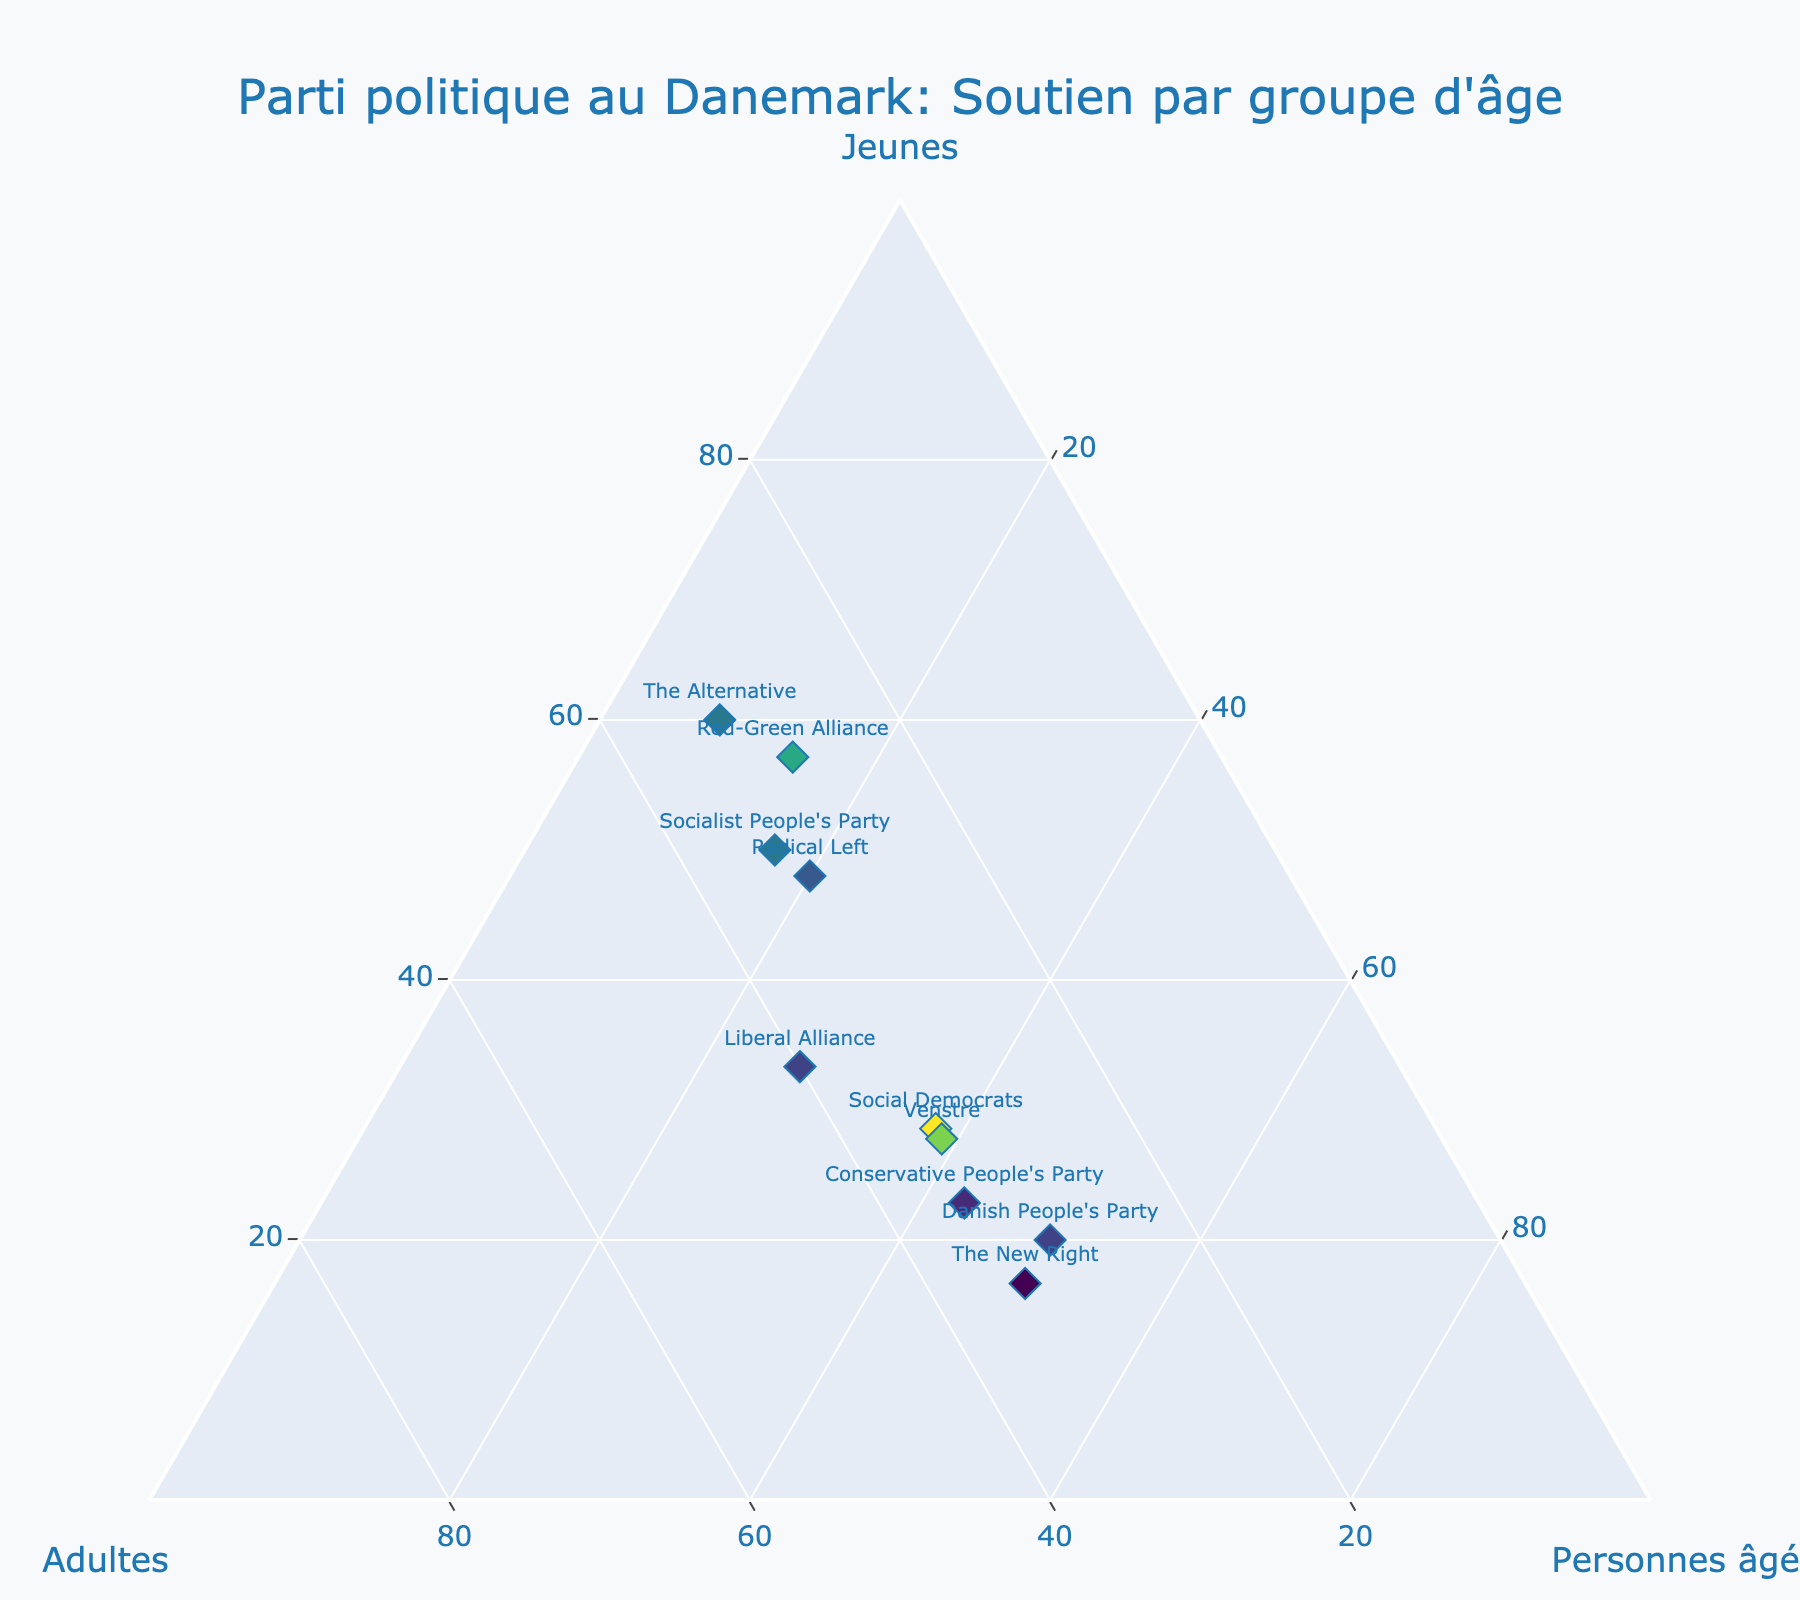What's the title of the plot? The title of the plot is located at the top center of the figure and usually presented in larger font size and distinct color to stand out.
Answer: Parti politique au Danemark: Soutien par groupe d'âge How many data points represent political parties in the plot? Each data point represents one political party, which can be identified by the text labels next to each marker. By counting these labels, you can find the number of political parties.
Answer: 10 Which political party has the highest support among the elderly? Look for the data point that is closest to the axis labeled "Personnes âgées" and observe the associated text label.
Answer: Social Democrats Which age group has the highest support for the "Red-Green Alliance"? Locate the data point labeled "Red-Green Alliance" and observe its position relative to the three axes.
Answer: Youth Is the support of "Venstre" more evenly distributed among the age groups compared to "The New Right"? Compare the positions of the data points for "Venstre" and "The New Right". "Venstre" is closer to the center of the ternary plot, indicating more even support across all age groups than "The New Right", which is closer to the elderly axis.
Answer: Yes What's the combined support in the elderly group for "Radical Left" and "The Alternative"? Identify the support values from the elderly group for both "Radical Left" (5) and "The Alternative" (2), then sum them up: 5 + 2 = 7.
Answer: 7 Which party has near equal support between adults and elderly but smallest support among the youth? Look for a data point that is positioned between the "Adultes" and "Personnes âgées" axes but closer to the "Youth" axis intersection.
Answer: The New Right What is the range of support percentages among the youth for all parties? Identify the minimum and maximum support values in the Youth column (5 for "The New Right", 30 for "Social Democrats") and subtract the minimum from the maximum: 30 - 5 = 25.
Answer: 25 What's the total support percentage for the "Danish People's Party" across all age groups? Sum up the support percentages for the youth, adults, and elderly for the "Danish People's Party": 10 (Youth) + 15 (Adults) + 25 (Elderly) = 50.
Answer: 50 Which party has the smallest difference in support between the youth and elderly groups? Calculate the differences in support between the youth and elderly for all parties, and then identify the smallest difference. The smallest difference is for the "Socialist People's Party" (15 - 5 = 10).
Answer: Socialist People's Party 